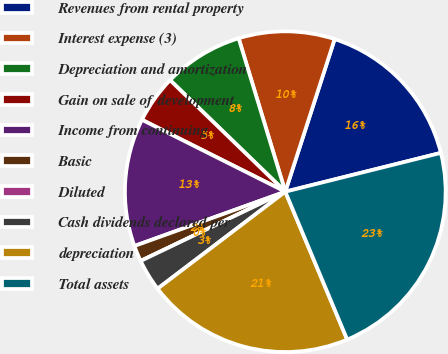<chart> <loc_0><loc_0><loc_500><loc_500><pie_chart><fcel>Revenues from rental property<fcel>Interest expense (3)<fcel>Depreciation and amortization<fcel>Gain on sale of development<fcel>Income from continuing<fcel>Basic<fcel>Diluted<fcel>Cash dividends declared per<fcel>depreciation<fcel>Total assets<nl><fcel>16.13%<fcel>9.68%<fcel>8.06%<fcel>4.84%<fcel>12.9%<fcel>1.61%<fcel>0.0%<fcel>3.23%<fcel>20.97%<fcel>22.58%<nl></chart> 